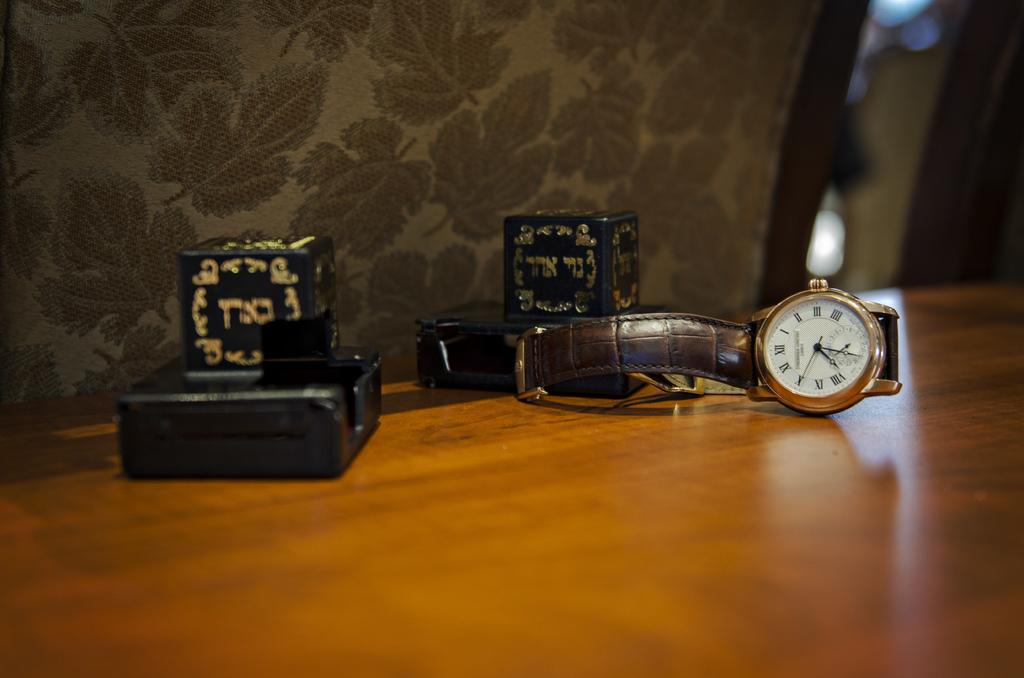<image>
Render a clear and concise summary of the photo. A gold bezeled watch with a leather band showing 7:30 on the face next to two black boxes. 